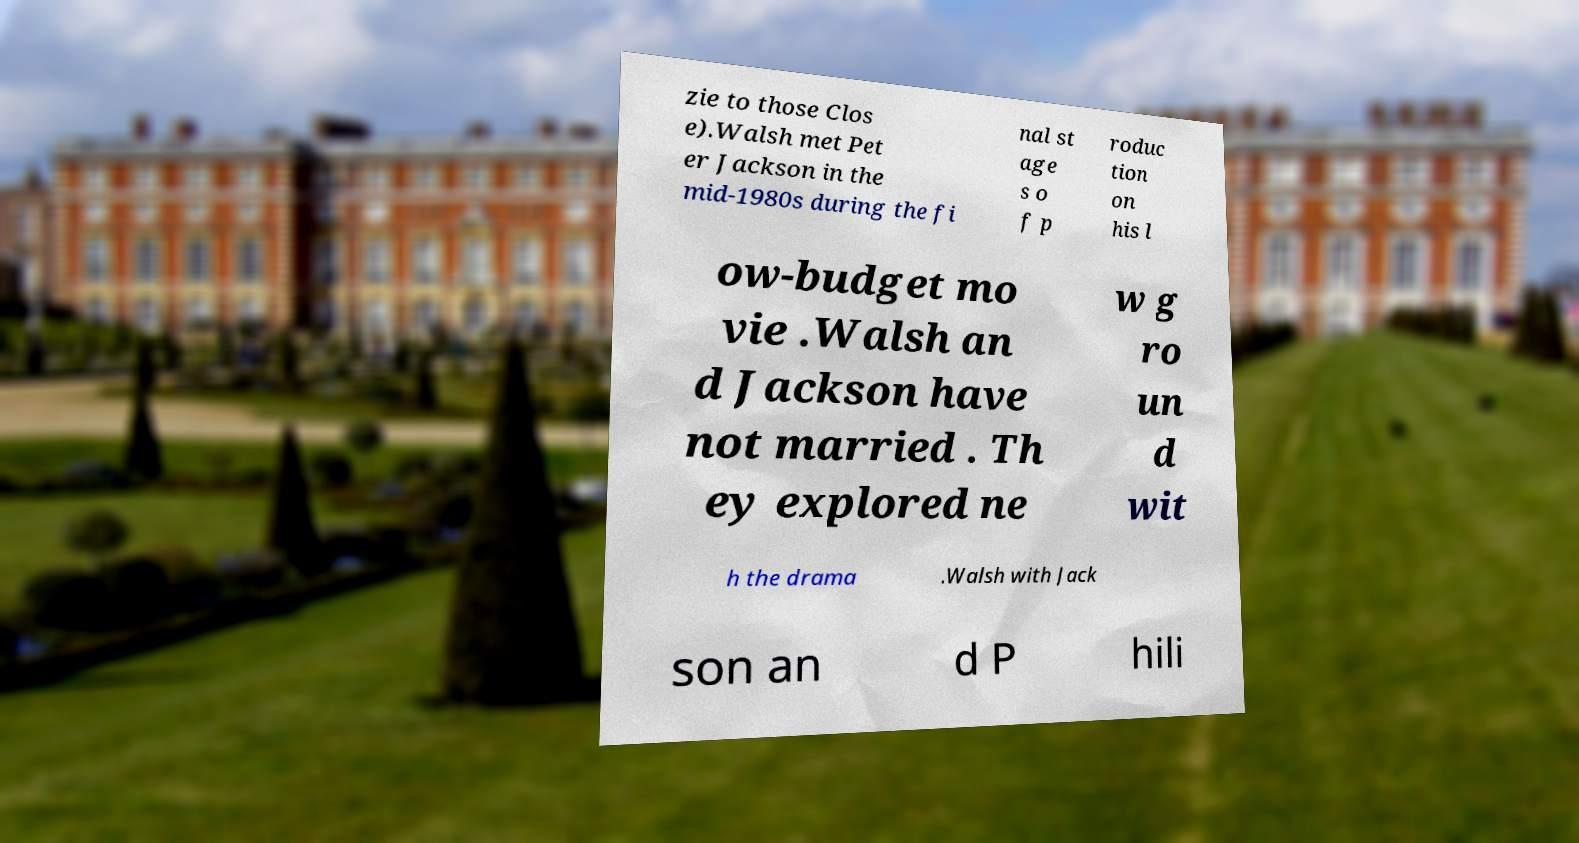Please read and relay the text visible in this image. What does it say? zie to those Clos e).Walsh met Pet er Jackson in the mid-1980s during the fi nal st age s o f p roduc tion on his l ow-budget mo vie .Walsh an d Jackson have not married . Th ey explored ne w g ro un d wit h the drama .Walsh with Jack son an d P hili 